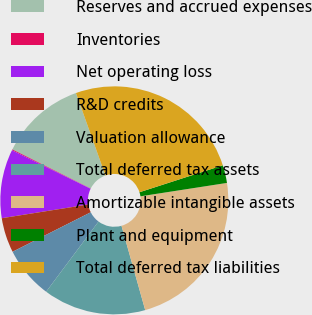Convert chart to OTSL. <chart><loc_0><loc_0><loc_500><loc_500><pie_chart><fcel>Reserves and accrued expenses<fcel>Inventories<fcel>Net operating loss<fcel>R&D credits<fcel>Valuation allowance<fcel>Total deferred tax assets<fcel>Amortizable intangible assets<fcel>Plant and equipment<fcel>Total deferred tax liabilities<nl><fcel>12.16%<fcel>0.13%<fcel>9.75%<fcel>4.94%<fcel>7.35%<fcel>14.57%<fcel>23.08%<fcel>2.53%<fcel>25.49%<nl></chart> 